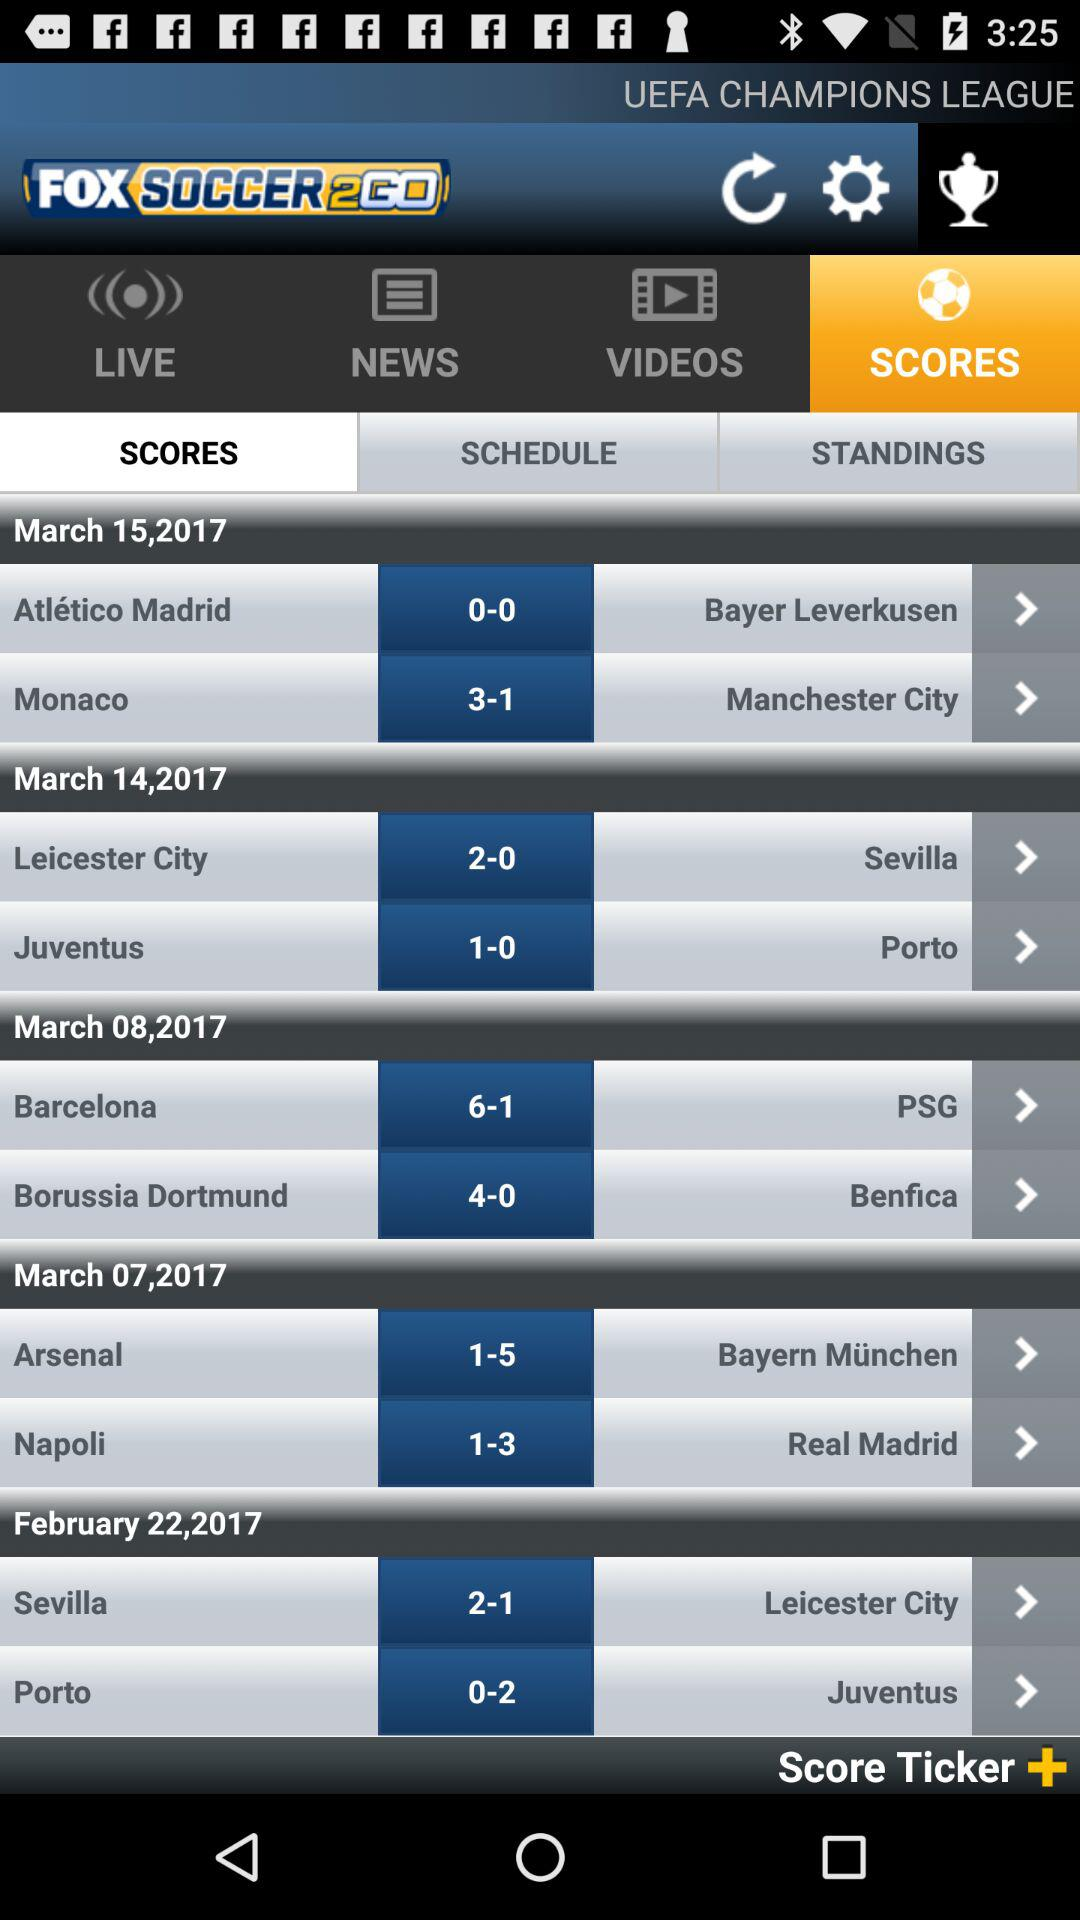What is the score between "Monaco" and "Manchester City"? The score is 3-1. 